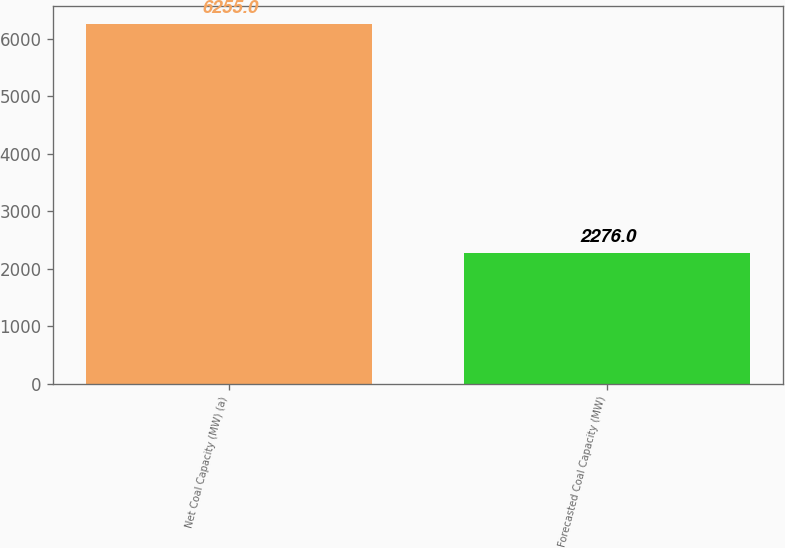Convert chart to OTSL. <chart><loc_0><loc_0><loc_500><loc_500><bar_chart><fcel>Net Coal Capacity (MW) (a)<fcel>Forecasted Coal Capacity (MW)<nl><fcel>6255<fcel>2276<nl></chart> 